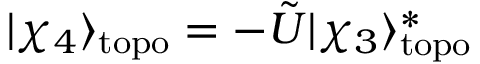<formula> <loc_0><loc_0><loc_500><loc_500>| \chi _ { 4 } \rangle _ { t o p o } = - \tilde { U } | \chi _ { 3 } \rangle _ { t o p o } ^ { * }</formula> 